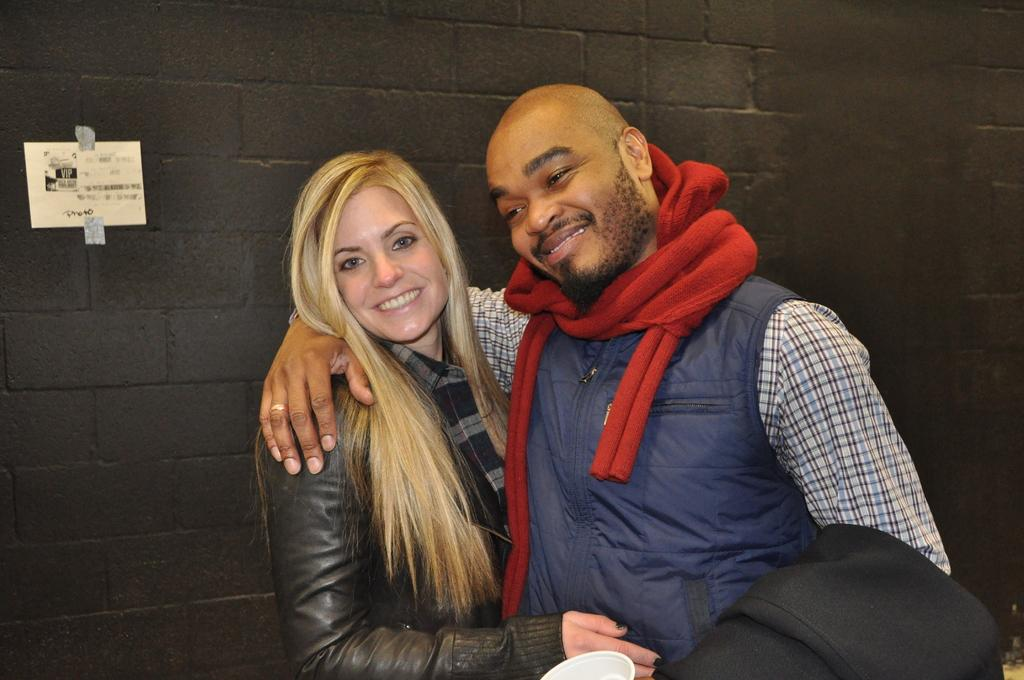How many people are present in the image? There are two people standing in the image. What can be seen in the background of the image? There is a wall in the background of the image. Is there anything on the wall in the background? Yes, there is a poster on the wall in the background. What type of insect is crawling on the poster in the image? There is no insect present on the poster in the image. 